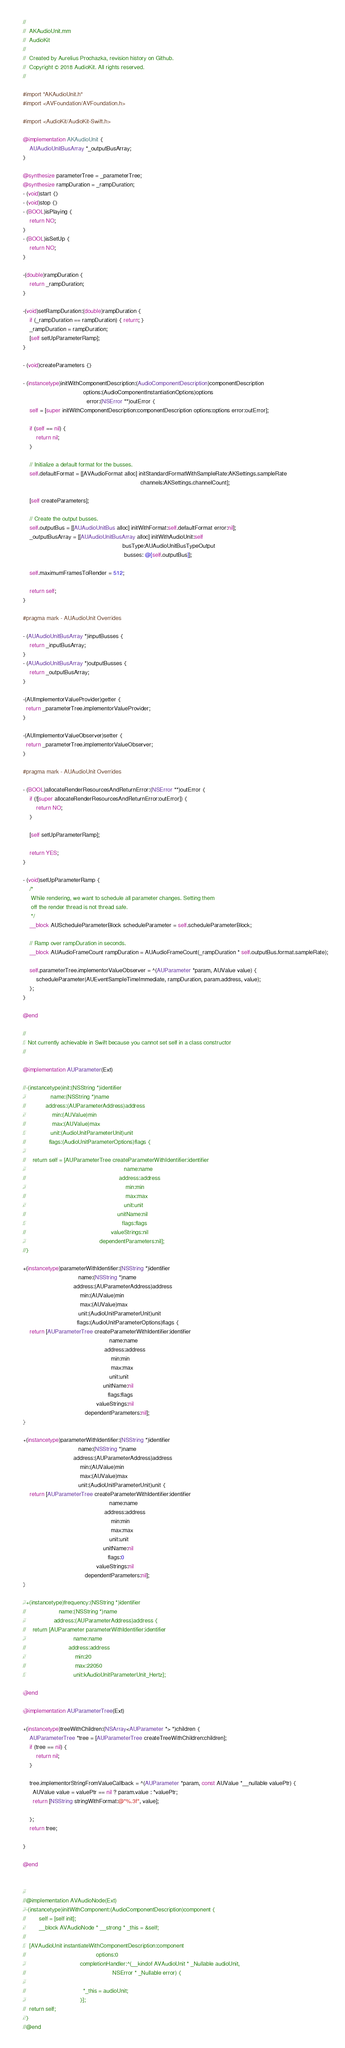Convert code to text. <code><loc_0><loc_0><loc_500><loc_500><_ObjectiveC_>//
//  AKAudioUnit.mm
//  AudioKit
//
//  Created by Aurelius Prochazka, revision history on Github.
//  Copyright © 2018 AudioKit. All rights reserved.
//

#import "AKAudioUnit.h"
#import <AVFoundation/AVFoundation.h>

#import <AudioKit/AudioKit-Swift.h>

@implementation AKAudioUnit {
    AUAudioUnitBusArray *_outputBusArray;
}

@synthesize parameterTree = _parameterTree;
@synthesize rampDuration = _rampDuration;
- (void)start {}
- (void)stop {}
- (BOOL)isPlaying {
    return NO;
}
- (BOOL)isSetUp {
    return NO;
}

-(double)rampDuration {
    return _rampDuration;
}

-(void)setRampDuration:(double)rampDuration {
    if (_rampDuration == rampDuration) { return; }
    _rampDuration = rampDuration;
    [self setUpParameterRamp];
}

- (void)createParameters {}

- (instancetype)initWithComponentDescription:(AudioComponentDescription)componentDescription
                                     options:(AudioComponentInstantiationOptions)options
                                       error:(NSError **)outError {
    self = [super initWithComponentDescription:componentDescription options:options error:outError];

    if (self == nil) {
        return nil;
    }

    // Initialize a default format for the busses.
    self.defaultFormat = [[AVAudioFormat alloc] initStandardFormatWithSampleRate:AKSettings.sampleRate
                                                                        channels:AKSettings.channelCount];

    [self createParameters];

    // Create the output busses.
    self.outputBus = [[AUAudioUnitBus alloc] initWithFormat:self.defaultFormat error:nil];
    _outputBusArray = [[AUAudioUnitBusArray alloc] initWithAudioUnit:self
                                                             busType:AUAudioUnitBusTypeOutput
                                                              busses: @[self.outputBus]];

    self.maximumFramesToRender = 512;

    return self;
}

#pragma mark - AUAudioUnit Overrides

- (AUAudioUnitBusArray *)inputBusses {
    return _inputBusArray;
}
- (AUAudioUnitBusArray *)outputBusses {
    return _outputBusArray;
}

-(AUImplementorValueProvider)getter {
  return _parameterTree.implementorValueProvider;
}

-(AUImplementorValueObserver)setter {
  return _parameterTree.implementorValueObserver;
}

#pragma mark - AUAudioUnit Overrides

- (BOOL)allocateRenderResourcesAndReturnError:(NSError **)outError {
    if (![super allocateRenderResourcesAndReturnError:outError]) {
        return NO;
    }

    [self setUpParameterRamp];

    return YES;
}

- (void)setUpParameterRamp {
    /*
     While rendering, we want to schedule all parameter changes. Setting them
     off the render thread is not thread safe.
     */
    __block AUScheduleParameterBlock scheduleParameter = self.scheduleParameterBlock;

    // Ramp over rampDuration in seconds.
    __block AUAudioFrameCount rampDuration = AUAudioFrameCount(_rampDuration * self.outputBus.format.sampleRate);

    self.parameterTree.implementorValueObserver = ^(AUParameter *param, AUValue value) {
        scheduleParameter(AUEventSampleTimeImmediate, rampDuration, param.address, value);
    };
}

@end

//
// Not currently achievable in Swift because you cannot set self in a class constructor
//

@implementation AUParameter(Ext)

//-(instancetype)init:(NSString *)identifier
//               name:(NSString *)name
//            address:(AUParameterAddress)address
//                min:(AUValue)min
//                max:(AUValue)max
//               unit:(AudioUnitParameterUnit)unit
//              flags:(AudioUnitParameterOptions)flags {
//
//    return self = [AUParameterTree createParameterWithIdentifier:identifier
//                                                            name:name
//                                                         address:address
//                                                             min:min
//                                                             max:max
//                                                            unit:unit
//                                                        unitName:nil
//                                                           flags:flags
//                                                    valueStrings:nil
//                                             dependentParameters:nil];
//}

+(instancetype)parameterWithIdentifier:(NSString *)identifier
                                  name:(NSString *)name
                               address:(AUParameterAddress)address
                                   min:(AUValue)min
                                   max:(AUValue)max
                                  unit:(AudioUnitParameterUnit)unit
                                 flags:(AudioUnitParameterOptions)flags {
    return [AUParameterTree createParameterWithIdentifier:identifier
                                                     name:name
                                                  address:address
                                                      min:min
                                                      max:max
                                                     unit:unit
                                                 unitName:nil
                                                    flags:flags
                                             valueStrings:nil
                                      dependentParameters:nil];
}

+(instancetype)parameterWithIdentifier:(NSString *)identifier
                                  name:(NSString *)name
                               address:(AUParameterAddress)address
                                   min:(AUValue)min
                                   max:(AUValue)max
                                  unit:(AudioUnitParameterUnit)unit {
    return [AUParameterTree createParameterWithIdentifier:identifier
                                                     name:name
                                                  address:address
                                                      min:min
                                                      max:max
                                                     unit:unit
                                                 unitName:nil
                                                    flags:0
                                             valueStrings:nil
                                      dependentParameters:nil];
}

//+(instancetype)frequency:(NSString *)identifier
//                    name:(NSString *)name
//                 address:(AUParameterAddress)address {
//    return [AUParameter parameterWithIdentifier:identifier
//                             name:name
//                          address:address
//                              min:20
//                              max:22050
//                             unit:kAudioUnitParameterUnit_Hertz];

@end

@implementation AUParameterTree(Ext)

+(instancetype)treeWithChildren:(NSArray<AUParameter *> *)children {
    AUParameterTree *tree = [AUParameterTree createTreeWithChildren:children];
    if (tree == nil) {
        return nil;
    }

    tree.implementorStringFromValueCallback = ^(AUParameter *param, const AUValue *__nullable valuePtr) {
      AUValue value = valuePtr == nil ? param.value : *valuePtr;
      return [NSString stringWithFormat:@"%.3f", value];

    };
    return tree;

}

@end


//
//@implementation AVAudioNode(Ext)
//-(instancetype)initWithComponent:(AudioComponentDescription)component {
//        self = [self init];
//        __block AVAudioNode * __strong * _this = &self;
//
//  [AVAudioUnit instantiateWithComponentDescription:component
//                                           options:0
//                                 completionHandler:^(__kindof AVAudioUnit * _Nullable audioUnit,
//                                                     NSError * _Nullable error) {
//
//                                   *_this = audioUnit;
//                                 }];
//  return self;
//}
//@end
</code> 